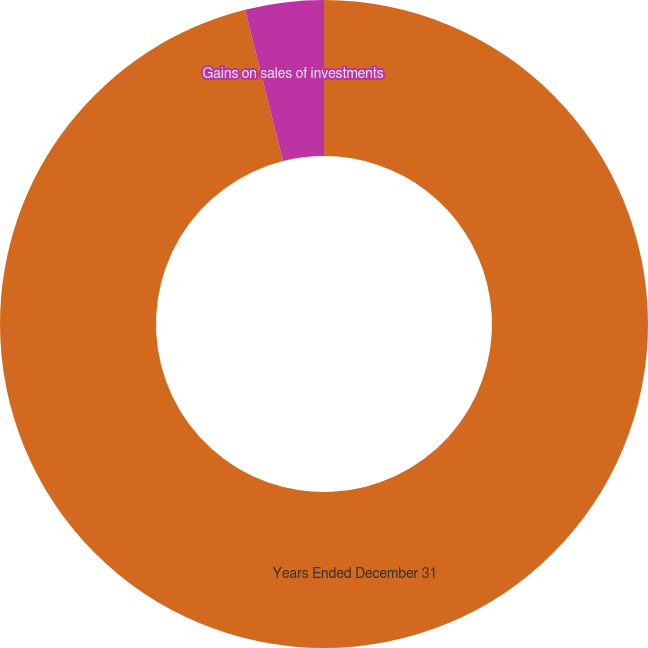<chart> <loc_0><loc_0><loc_500><loc_500><pie_chart><fcel>Years Ended December 31<fcel>Gains on sales of investments<nl><fcel>96.08%<fcel>3.92%<nl></chart> 